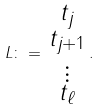Convert formula to latex. <formula><loc_0><loc_0><loc_500><loc_500>L \colon = \begin{smallmatrix} t _ { j } \\ t _ { j + 1 } \\ \vdots \\ t _ { \ell } \end{smallmatrix} .</formula> 